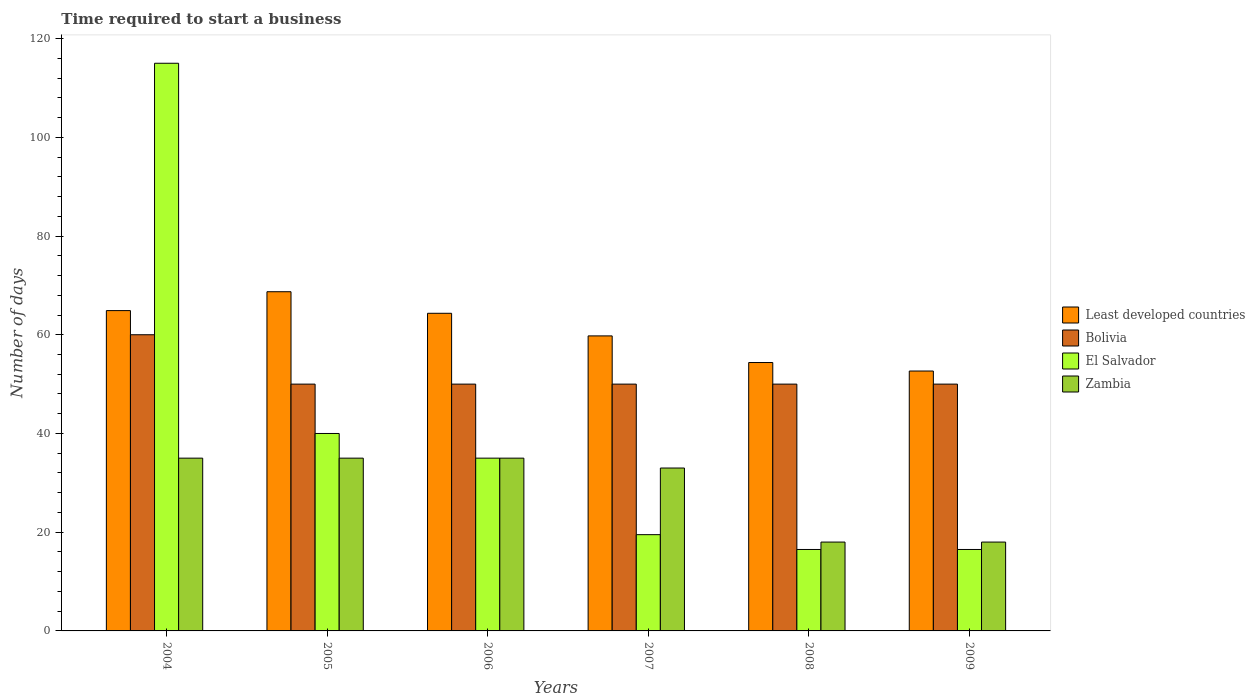How many different coloured bars are there?
Your response must be concise. 4. What is the number of days required to start a business in El Salvador in 2004?
Ensure brevity in your answer.  115. Across all years, what is the maximum number of days required to start a business in El Salvador?
Offer a very short reply. 115. Across all years, what is the minimum number of days required to start a business in Least developed countries?
Your answer should be compact. 52.65. In which year was the number of days required to start a business in Bolivia maximum?
Give a very brief answer. 2004. What is the total number of days required to start a business in El Salvador in the graph?
Your answer should be very brief. 242.5. What is the difference between the number of days required to start a business in Least developed countries in 2004 and that in 2008?
Offer a very short reply. 10.52. What is the difference between the number of days required to start a business in Zambia in 2005 and the number of days required to start a business in Bolivia in 2004?
Ensure brevity in your answer.  -25. What is the average number of days required to start a business in El Salvador per year?
Provide a short and direct response. 40.42. In the year 2005, what is the difference between the number of days required to start a business in Least developed countries and number of days required to start a business in El Salvador?
Make the answer very short. 28.71. What is the ratio of the number of days required to start a business in Least developed countries in 2004 to that in 2005?
Make the answer very short. 0.94. What is the difference between the highest and the second highest number of days required to start a business in Zambia?
Ensure brevity in your answer.  0. What is the difference between the highest and the lowest number of days required to start a business in El Salvador?
Ensure brevity in your answer.  98.5. Is the sum of the number of days required to start a business in El Salvador in 2005 and 2009 greater than the maximum number of days required to start a business in Bolivia across all years?
Provide a succinct answer. No. What does the 4th bar from the left in 2005 represents?
Give a very brief answer. Zambia. What does the 1st bar from the right in 2007 represents?
Keep it short and to the point. Zambia. Does the graph contain grids?
Offer a terse response. No. What is the title of the graph?
Your response must be concise. Time required to start a business. What is the label or title of the X-axis?
Keep it short and to the point. Years. What is the label or title of the Y-axis?
Your answer should be compact. Number of days. What is the Number of days in Least developed countries in 2004?
Offer a terse response. 64.89. What is the Number of days of El Salvador in 2004?
Give a very brief answer. 115. What is the Number of days of Zambia in 2004?
Ensure brevity in your answer.  35. What is the Number of days of Least developed countries in 2005?
Keep it short and to the point. 68.71. What is the Number of days in El Salvador in 2005?
Give a very brief answer. 40. What is the Number of days in Least developed countries in 2006?
Make the answer very short. 64.35. What is the Number of days of Bolivia in 2006?
Provide a succinct answer. 50. What is the Number of days of El Salvador in 2006?
Give a very brief answer. 35. What is the Number of days of Zambia in 2006?
Offer a very short reply. 35. What is the Number of days of Least developed countries in 2007?
Give a very brief answer. 59.77. What is the Number of days of Bolivia in 2007?
Your answer should be very brief. 50. What is the Number of days of Least developed countries in 2008?
Provide a succinct answer. 54.37. What is the Number of days in Zambia in 2008?
Offer a very short reply. 18. What is the Number of days of Least developed countries in 2009?
Offer a terse response. 52.65. What is the Number of days of El Salvador in 2009?
Offer a very short reply. 16.5. Across all years, what is the maximum Number of days in Least developed countries?
Give a very brief answer. 68.71. Across all years, what is the maximum Number of days in Bolivia?
Keep it short and to the point. 60. Across all years, what is the maximum Number of days in El Salvador?
Your response must be concise. 115. Across all years, what is the maximum Number of days in Zambia?
Offer a terse response. 35. Across all years, what is the minimum Number of days in Least developed countries?
Keep it short and to the point. 52.65. Across all years, what is the minimum Number of days of Zambia?
Your answer should be compact. 18. What is the total Number of days of Least developed countries in the graph?
Ensure brevity in your answer.  364.75. What is the total Number of days of Bolivia in the graph?
Give a very brief answer. 310. What is the total Number of days in El Salvador in the graph?
Provide a succinct answer. 242.5. What is the total Number of days in Zambia in the graph?
Your answer should be very brief. 174. What is the difference between the Number of days of Least developed countries in 2004 and that in 2005?
Provide a short and direct response. -3.82. What is the difference between the Number of days of Bolivia in 2004 and that in 2005?
Keep it short and to the point. 10. What is the difference between the Number of days of Least developed countries in 2004 and that in 2006?
Offer a very short reply. 0.54. What is the difference between the Number of days of El Salvador in 2004 and that in 2006?
Offer a very short reply. 80. What is the difference between the Number of days in Zambia in 2004 and that in 2006?
Offer a terse response. 0. What is the difference between the Number of days in Least developed countries in 2004 and that in 2007?
Make the answer very short. 5.12. What is the difference between the Number of days of El Salvador in 2004 and that in 2007?
Ensure brevity in your answer.  95.5. What is the difference between the Number of days in Least developed countries in 2004 and that in 2008?
Make the answer very short. 10.52. What is the difference between the Number of days in Bolivia in 2004 and that in 2008?
Ensure brevity in your answer.  10. What is the difference between the Number of days in El Salvador in 2004 and that in 2008?
Your answer should be compact. 98.5. What is the difference between the Number of days in Zambia in 2004 and that in 2008?
Make the answer very short. 17. What is the difference between the Number of days of Least developed countries in 2004 and that in 2009?
Your answer should be very brief. 12.24. What is the difference between the Number of days of El Salvador in 2004 and that in 2009?
Your answer should be very brief. 98.5. What is the difference between the Number of days in Zambia in 2004 and that in 2009?
Provide a short and direct response. 17. What is the difference between the Number of days in Least developed countries in 2005 and that in 2006?
Give a very brief answer. 4.37. What is the difference between the Number of days in Bolivia in 2005 and that in 2006?
Your answer should be very brief. 0. What is the difference between the Number of days of Zambia in 2005 and that in 2006?
Give a very brief answer. 0. What is the difference between the Number of days in Least developed countries in 2005 and that in 2007?
Give a very brief answer. 8.95. What is the difference between the Number of days in Least developed countries in 2005 and that in 2008?
Your answer should be compact. 14.34. What is the difference between the Number of days of Zambia in 2005 and that in 2008?
Offer a terse response. 17. What is the difference between the Number of days of Least developed countries in 2005 and that in 2009?
Ensure brevity in your answer.  16.06. What is the difference between the Number of days in El Salvador in 2005 and that in 2009?
Offer a very short reply. 23.5. What is the difference between the Number of days of Zambia in 2005 and that in 2009?
Provide a short and direct response. 17. What is the difference between the Number of days of Least developed countries in 2006 and that in 2007?
Keep it short and to the point. 4.58. What is the difference between the Number of days of Zambia in 2006 and that in 2007?
Your response must be concise. 2. What is the difference between the Number of days in Least developed countries in 2006 and that in 2008?
Your answer should be compact. 9.98. What is the difference between the Number of days of Bolivia in 2006 and that in 2008?
Your answer should be compact. 0. What is the difference between the Number of days in El Salvador in 2006 and that in 2008?
Your answer should be very brief. 18.5. What is the difference between the Number of days in Least developed countries in 2006 and that in 2009?
Provide a succinct answer. 11.7. What is the difference between the Number of days of El Salvador in 2006 and that in 2009?
Offer a very short reply. 18.5. What is the difference between the Number of days in Zambia in 2006 and that in 2009?
Offer a very short reply. 17. What is the difference between the Number of days in Least developed countries in 2007 and that in 2008?
Offer a very short reply. 5.4. What is the difference between the Number of days of Bolivia in 2007 and that in 2008?
Offer a very short reply. 0. What is the difference between the Number of days in El Salvador in 2007 and that in 2008?
Give a very brief answer. 3. What is the difference between the Number of days of Least developed countries in 2007 and that in 2009?
Your answer should be compact. 7.12. What is the difference between the Number of days in Bolivia in 2007 and that in 2009?
Your answer should be compact. 0. What is the difference between the Number of days of Least developed countries in 2008 and that in 2009?
Offer a very short reply. 1.72. What is the difference between the Number of days of Bolivia in 2008 and that in 2009?
Your response must be concise. 0. What is the difference between the Number of days in El Salvador in 2008 and that in 2009?
Keep it short and to the point. 0. What is the difference between the Number of days of Least developed countries in 2004 and the Number of days of Bolivia in 2005?
Provide a short and direct response. 14.89. What is the difference between the Number of days of Least developed countries in 2004 and the Number of days of El Salvador in 2005?
Provide a succinct answer. 24.89. What is the difference between the Number of days of Least developed countries in 2004 and the Number of days of Zambia in 2005?
Make the answer very short. 29.89. What is the difference between the Number of days in Bolivia in 2004 and the Number of days in Zambia in 2005?
Ensure brevity in your answer.  25. What is the difference between the Number of days of Least developed countries in 2004 and the Number of days of Bolivia in 2006?
Offer a terse response. 14.89. What is the difference between the Number of days of Least developed countries in 2004 and the Number of days of El Salvador in 2006?
Provide a short and direct response. 29.89. What is the difference between the Number of days of Least developed countries in 2004 and the Number of days of Zambia in 2006?
Offer a terse response. 29.89. What is the difference between the Number of days of Bolivia in 2004 and the Number of days of El Salvador in 2006?
Keep it short and to the point. 25. What is the difference between the Number of days of El Salvador in 2004 and the Number of days of Zambia in 2006?
Your answer should be compact. 80. What is the difference between the Number of days in Least developed countries in 2004 and the Number of days in Bolivia in 2007?
Ensure brevity in your answer.  14.89. What is the difference between the Number of days of Least developed countries in 2004 and the Number of days of El Salvador in 2007?
Ensure brevity in your answer.  45.39. What is the difference between the Number of days of Least developed countries in 2004 and the Number of days of Zambia in 2007?
Your answer should be very brief. 31.89. What is the difference between the Number of days of Bolivia in 2004 and the Number of days of El Salvador in 2007?
Give a very brief answer. 40.5. What is the difference between the Number of days of Least developed countries in 2004 and the Number of days of Bolivia in 2008?
Ensure brevity in your answer.  14.89. What is the difference between the Number of days of Least developed countries in 2004 and the Number of days of El Salvador in 2008?
Your answer should be compact. 48.39. What is the difference between the Number of days in Least developed countries in 2004 and the Number of days in Zambia in 2008?
Keep it short and to the point. 46.89. What is the difference between the Number of days in Bolivia in 2004 and the Number of days in El Salvador in 2008?
Make the answer very short. 43.5. What is the difference between the Number of days of Bolivia in 2004 and the Number of days of Zambia in 2008?
Ensure brevity in your answer.  42. What is the difference between the Number of days in El Salvador in 2004 and the Number of days in Zambia in 2008?
Keep it short and to the point. 97. What is the difference between the Number of days in Least developed countries in 2004 and the Number of days in Bolivia in 2009?
Your response must be concise. 14.89. What is the difference between the Number of days of Least developed countries in 2004 and the Number of days of El Salvador in 2009?
Your answer should be very brief. 48.39. What is the difference between the Number of days in Least developed countries in 2004 and the Number of days in Zambia in 2009?
Ensure brevity in your answer.  46.89. What is the difference between the Number of days of Bolivia in 2004 and the Number of days of El Salvador in 2009?
Ensure brevity in your answer.  43.5. What is the difference between the Number of days in Bolivia in 2004 and the Number of days in Zambia in 2009?
Provide a short and direct response. 42. What is the difference between the Number of days of El Salvador in 2004 and the Number of days of Zambia in 2009?
Provide a short and direct response. 97. What is the difference between the Number of days in Least developed countries in 2005 and the Number of days in Bolivia in 2006?
Offer a terse response. 18.71. What is the difference between the Number of days of Least developed countries in 2005 and the Number of days of El Salvador in 2006?
Offer a terse response. 33.71. What is the difference between the Number of days of Least developed countries in 2005 and the Number of days of Zambia in 2006?
Give a very brief answer. 33.71. What is the difference between the Number of days of Bolivia in 2005 and the Number of days of Zambia in 2006?
Provide a succinct answer. 15. What is the difference between the Number of days in Least developed countries in 2005 and the Number of days in Bolivia in 2007?
Your answer should be compact. 18.71. What is the difference between the Number of days in Least developed countries in 2005 and the Number of days in El Salvador in 2007?
Ensure brevity in your answer.  49.21. What is the difference between the Number of days of Least developed countries in 2005 and the Number of days of Zambia in 2007?
Provide a succinct answer. 35.71. What is the difference between the Number of days of Bolivia in 2005 and the Number of days of El Salvador in 2007?
Provide a short and direct response. 30.5. What is the difference between the Number of days of Bolivia in 2005 and the Number of days of Zambia in 2007?
Your answer should be compact. 17. What is the difference between the Number of days in El Salvador in 2005 and the Number of days in Zambia in 2007?
Your answer should be very brief. 7. What is the difference between the Number of days in Least developed countries in 2005 and the Number of days in Bolivia in 2008?
Keep it short and to the point. 18.71. What is the difference between the Number of days of Least developed countries in 2005 and the Number of days of El Salvador in 2008?
Your response must be concise. 52.21. What is the difference between the Number of days of Least developed countries in 2005 and the Number of days of Zambia in 2008?
Provide a succinct answer. 50.71. What is the difference between the Number of days in Bolivia in 2005 and the Number of days in El Salvador in 2008?
Give a very brief answer. 33.5. What is the difference between the Number of days in Least developed countries in 2005 and the Number of days in Bolivia in 2009?
Give a very brief answer. 18.71. What is the difference between the Number of days of Least developed countries in 2005 and the Number of days of El Salvador in 2009?
Your answer should be very brief. 52.21. What is the difference between the Number of days of Least developed countries in 2005 and the Number of days of Zambia in 2009?
Offer a terse response. 50.71. What is the difference between the Number of days in Bolivia in 2005 and the Number of days in El Salvador in 2009?
Provide a short and direct response. 33.5. What is the difference between the Number of days in Bolivia in 2005 and the Number of days in Zambia in 2009?
Offer a very short reply. 32. What is the difference between the Number of days of Least developed countries in 2006 and the Number of days of Bolivia in 2007?
Keep it short and to the point. 14.35. What is the difference between the Number of days of Least developed countries in 2006 and the Number of days of El Salvador in 2007?
Ensure brevity in your answer.  44.85. What is the difference between the Number of days of Least developed countries in 2006 and the Number of days of Zambia in 2007?
Your response must be concise. 31.35. What is the difference between the Number of days in Bolivia in 2006 and the Number of days in El Salvador in 2007?
Your answer should be very brief. 30.5. What is the difference between the Number of days of Bolivia in 2006 and the Number of days of Zambia in 2007?
Your answer should be compact. 17. What is the difference between the Number of days of El Salvador in 2006 and the Number of days of Zambia in 2007?
Provide a short and direct response. 2. What is the difference between the Number of days of Least developed countries in 2006 and the Number of days of Bolivia in 2008?
Keep it short and to the point. 14.35. What is the difference between the Number of days of Least developed countries in 2006 and the Number of days of El Salvador in 2008?
Provide a succinct answer. 47.85. What is the difference between the Number of days of Least developed countries in 2006 and the Number of days of Zambia in 2008?
Offer a very short reply. 46.35. What is the difference between the Number of days of Bolivia in 2006 and the Number of days of El Salvador in 2008?
Your answer should be compact. 33.5. What is the difference between the Number of days of Bolivia in 2006 and the Number of days of Zambia in 2008?
Your response must be concise. 32. What is the difference between the Number of days in El Salvador in 2006 and the Number of days in Zambia in 2008?
Your answer should be very brief. 17. What is the difference between the Number of days in Least developed countries in 2006 and the Number of days in Bolivia in 2009?
Your response must be concise. 14.35. What is the difference between the Number of days in Least developed countries in 2006 and the Number of days in El Salvador in 2009?
Keep it short and to the point. 47.85. What is the difference between the Number of days in Least developed countries in 2006 and the Number of days in Zambia in 2009?
Offer a terse response. 46.35. What is the difference between the Number of days of Bolivia in 2006 and the Number of days of El Salvador in 2009?
Ensure brevity in your answer.  33.5. What is the difference between the Number of days of Bolivia in 2006 and the Number of days of Zambia in 2009?
Offer a very short reply. 32. What is the difference between the Number of days in El Salvador in 2006 and the Number of days in Zambia in 2009?
Make the answer very short. 17. What is the difference between the Number of days of Least developed countries in 2007 and the Number of days of Bolivia in 2008?
Offer a very short reply. 9.77. What is the difference between the Number of days in Least developed countries in 2007 and the Number of days in El Salvador in 2008?
Your response must be concise. 43.27. What is the difference between the Number of days of Least developed countries in 2007 and the Number of days of Zambia in 2008?
Keep it short and to the point. 41.77. What is the difference between the Number of days of Bolivia in 2007 and the Number of days of El Salvador in 2008?
Your response must be concise. 33.5. What is the difference between the Number of days in Least developed countries in 2007 and the Number of days in Bolivia in 2009?
Make the answer very short. 9.77. What is the difference between the Number of days of Least developed countries in 2007 and the Number of days of El Salvador in 2009?
Your response must be concise. 43.27. What is the difference between the Number of days of Least developed countries in 2007 and the Number of days of Zambia in 2009?
Offer a very short reply. 41.77. What is the difference between the Number of days in Bolivia in 2007 and the Number of days in El Salvador in 2009?
Offer a very short reply. 33.5. What is the difference between the Number of days in Bolivia in 2007 and the Number of days in Zambia in 2009?
Make the answer very short. 32. What is the difference between the Number of days in Least developed countries in 2008 and the Number of days in Bolivia in 2009?
Offer a terse response. 4.37. What is the difference between the Number of days in Least developed countries in 2008 and the Number of days in El Salvador in 2009?
Provide a succinct answer. 37.87. What is the difference between the Number of days in Least developed countries in 2008 and the Number of days in Zambia in 2009?
Your response must be concise. 36.37. What is the difference between the Number of days of Bolivia in 2008 and the Number of days of El Salvador in 2009?
Make the answer very short. 33.5. What is the difference between the Number of days of Bolivia in 2008 and the Number of days of Zambia in 2009?
Ensure brevity in your answer.  32. What is the difference between the Number of days of El Salvador in 2008 and the Number of days of Zambia in 2009?
Give a very brief answer. -1.5. What is the average Number of days of Least developed countries per year?
Keep it short and to the point. 60.79. What is the average Number of days of Bolivia per year?
Keep it short and to the point. 51.67. What is the average Number of days of El Salvador per year?
Offer a terse response. 40.42. What is the average Number of days in Zambia per year?
Offer a terse response. 29. In the year 2004, what is the difference between the Number of days in Least developed countries and Number of days in Bolivia?
Your answer should be compact. 4.89. In the year 2004, what is the difference between the Number of days in Least developed countries and Number of days in El Salvador?
Offer a terse response. -50.11. In the year 2004, what is the difference between the Number of days of Least developed countries and Number of days of Zambia?
Provide a succinct answer. 29.89. In the year 2004, what is the difference between the Number of days of Bolivia and Number of days of El Salvador?
Provide a short and direct response. -55. In the year 2004, what is the difference between the Number of days in Bolivia and Number of days in Zambia?
Provide a short and direct response. 25. In the year 2004, what is the difference between the Number of days in El Salvador and Number of days in Zambia?
Your answer should be very brief. 80. In the year 2005, what is the difference between the Number of days in Least developed countries and Number of days in Bolivia?
Make the answer very short. 18.71. In the year 2005, what is the difference between the Number of days of Least developed countries and Number of days of El Salvador?
Your answer should be very brief. 28.71. In the year 2005, what is the difference between the Number of days of Least developed countries and Number of days of Zambia?
Provide a succinct answer. 33.71. In the year 2005, what is the difference between the Number of days of Bolivia and Number of days of El Salvador?
Offer a very short reply. 10. In the year 2005, what is the difference between the Number of days of Bolivia and Number of days of Zambia?
Offer a very short reply. 15. In the year 2006, what is the difference between the Number of days of Least developed countries and Number of days of Bolivia?
Your answer should be very brief. 14.35. In the year 2006, what is the difference between the Number of days in Least developed countries and Number of days in El Salvador?
Your response must be concise. 29.35. In the year 2006, what is the difference between the Number of days of Least developed countries and Number of days of Zambia?
Provide a short and direct response. 29.35. In the year 2006, what is the difference between the Number of days in Bolivia and Number of days in Zambia?
Provide a succinct answer. 15. In the year 2006, what is the difference between the Number of days of El Salvador and Number of days of Zambia?
Ensure brevity in your answer.  0. In the year 2007, what is the difference between the Number of days of Least developed countries and Number of days of Bolivia?
Ensure brevity in your answer.  9.77. In the year 2007, what is the difference between the Number of days of Least developed countries and Number of days of El Salvador?
Offer a terse response. 40.27. In the year 2007, what is the difference between the Number of days in Least developed countries and Number of days in Zambia?
Your response must be concise. 26.77. In the year 2007, what is the difference between the Number of days of Bolivia and Number of days of El Salvador?
Provide a succinct answer. 30.5. In the year 2007, what is the difference between the Number of days of El Salvador and Number of days of Zambia?
Keep it short and to the point. -13.5. In the year 2008, what is the difference between the Number of days of Least developed countries and Number of days of Bolivia?
Give a very brief answer. 4.37. In the year 2008, what is the difference between the Number of days of Least developed countries and Number of days of El Salvador?
Ensure brevity in your answer.  37.87. In the year 2008, what is the difference between the Number of days in Least developed countries and Number of days in Zambia?
Offer a terse response. 36.37. In the year 2008, what is the difference between the Number of days of Bolivia and Number of days of El Salvador?
Provide a succinct answer. 33.5. In the year 2008, what is the difference between the Number of days of El Salvador and Number of days of Zambia?
Your answer should be compact. -1.5. In the year 2009, what is the difference between the Number of days of Least developed countries and Number of days of Bolivia?
Keep it short and to the point. 2.65. In the year 2009, what is the difference between the Number of days of Least developed countries and Number of days of El Salvador?
Provide a short and direct response. 36.15. In the year 2009, what is the difference between the Number of days in Least developed countries and Number of days in Zambia?
Your answer should be very brief. 34.65. In the year 2009, what is the difference between the Number of days in Bolivia and Number of days in El Salvador?
Your answer should be compact. 33.5. In the year 2009, what is the difference between the Number of days in Bolivia and Number of days in Zambia?
Ensure brevity in your answer.  32. In the year 2009, what is the difference between the Number of days in El Salvador and Number of days in Zambia?
Keep it short and to the point. -1.5. What is the ratio of the Number of days of Least developed countries in 2004 to that in 2005?
Your answer should be compact. 0.94. What is the ratio of the Number of days in Bolivia in 2004 to that in 2005?
Keep it short and to the point. 1.2. What is the ratio of the Number of days of El Salvador in 2004 to that in 2005?
Your answer should be very brief. 2.88. What is the ratio of the Number of days of Zambia in 2004 to that in 2005?
Make the answer very short. 1. What is the ratio of the Number of days in Least developed countries in 2004 to that in 2006?
Your answer should be very brief. 1.01. What is the ratio of the Number of days of Bolivia in 2004 to that in 2006?
Make the answer very short. 1.2. What is the ratio of the Number of days in El Salvador in 2004 to that in 2006?
Offer a terse response. 3.29. What is the ratio of the Number of days in Least developed countries in 2004 to that in 2007?
Keep it short and to the point. 1.09. What is the ratio of the Number of days of El Salvador in 2004 to that in 2007?
Your answer should be compact. 5.9. What is the ratio of the Number of days in Zambia in 2004 to that in 2007?
Offer a terse response. 1.06. What is the ratio of the Number of days of Least developed countries in 2004 to that in 2008?
Make the answer very short. 1.19. What is the ratio of the Number of days in El Salvador in 2004 to that in 2008?
Ensure brevity in your answer.  6.97. What is the ratio of the Number of days in Zambia in 2004 to that in 2008?
Your answer should be very brief. 1.94. What is the ratio of the Number of days of Least developed countries in 2004 to that in 2009?
Give a very brief answer. 1.23. What is the ratio of the Number of days in El Salvador in 2004 to that in 2009?
Make the answer very short. 6.97. What is the ratio of the Number of days of Zambia in 2004 to that in 2009?
Ensure brevity in your answer.  1.94. What is the ratio of the Number of days in Least developed countries in 2005 to that in 2006?
Your answer should be very brief. 1.07. What is the ratio of the Number of days of Bolivia in 2005 to that in 2006?
Provide a short and direct response. 1. What is the ratio of the Number of days in Zambia in 2005 to that in 2006?
Your answer should be very brief. 1. What is the ratio of the Number of days of Least developed countries in 2005 to that in 2007?
Your answer should be compact. 1.15. What is the ratio of the Number of days of Bolivia in 2005 to that in 2007?
Your answer should be very brief. 1. What is the ratio of the Number of days in El Salvador in 2005 to that in 2007?
Your response must be concise. 2.05. What is the ratio of the Number of days in Zambia in 2005 to that in 2007?
Give a very brief answer. 1.06. What is the ratio of the Number of days of Least developed countries in 2005 to that in 2008?
Provide a short and direct response. 1.26. What is the ratio of the Number of days of Bolivia in 2005 to that in 2008?
Offer a terse response. 1. What is the ratio of the Number of days of El Salvador in 2005 to that in 2008?
Make the answer very short. 2.42. What is the ratio of the Number of days in Zambia in 2005 to that in 2008?
Your response must be concise. 1.94. What is the ratio of the Number of days of Least developed countries in 2005 to that in 2009?
Ensure brevity in your answer.  1.31. What is the ratio of the Number of days of El Salvador in 2005 to that in 2009?
Keep it short and to the point. 2.42. What is the ratio of the Number of days of Zambia in 2005 to that in 2009?
Keep it short and to the point. 1.94. What is the ratio of the Number of days in Least developed countries in 2006 to that in 2007?
Provide a short and direct response. 1.08. What is the ratio of the Number of days in Bolivia in 2006 to that in 2007?
Your answer should be very brief. 1. What is the ratio of the Number of days in El Salvador in 2006 to that in 2007?
Your answer should be compact. 1.79. What is the ratio of the Number of days in Zambia in 2006 to that in 2007?
Your answer should be very brief. 1.06. What is the ratio of the Number of days of Least developed countries in 2006 to that in 2008?
Ensure brevity in your answer.  1.18. What is the ratio of the Number of days of El Salvador in 2006 to that in 2008?
Your answer should be very brief. 2.12. What is the ratio of the Number of days in Zambia in 2006 to that in 2008?
Make the answer very short. 1.94. What is the ratio of the Number of days in Least developed countries in 2006 to that in 2009?
Keep it short and to the point. 1.22. What is the ratio of the Number of days in El Salvador in 2006 to that in 2009?
Your response must be concise. 2.12. What is the ratio of the Number of days in Zambia in 2006 to that in 2009?
Offer a very short reply. 1.94. What is the ratio of the Number of days of Least developed countries in 2007 to that in 2008?
Your response must be concise. 1.1. What is the ratio of the Number of days in Bolivia in 2007 to that in 2008?
Provide a succinct answer. 1. What is the ratio of the Number of days of El Salvador in 2007 to that in 2008?
Provide a succinct answer. 1.18. What is the ratio of the Number of days of Zambia in 2007 to that in 2008?
Provide a short and direct response. 1.83. What is the ratio of the Number of days of Least developed countries in 2007 to that in 2009?
Provide a succinct answer. 1.14. What is the ratio of the Number of days in El Salvador in 2007 to that in 2009?
Your response must be concise. 1.18. What is the ratio of the Number of days of Zambia in 2007 to that in 2009?
Give a very brief answer. 1.83. What is the ratio of the Number of days of Least developed countries in 2008 to that in 2009?
Your response must be concise. 1.03. What is the ratio of the Number of days in Bolivia in 2008 to that in 2009?
Offer a very short reply. 1. What is the ratio of the Number of days in El Salvador in 2008 to that in 2009?
Make the answer very short. 1. What is the difference between the highest and the second highest Number of days of Least developed countries?
Offer a terse response. 3.82. What is the difference between the highest and the second highest Number of days in Zambia?
Provide a succinct answer. 0. What is the difference between the highest and the lowest Number of days in Least developed countries?
Give a very brief answer. 16.06. What is the difference between the highest and the lowest Number of days of El Salvador?
Your answer should be compact. 98.5. 